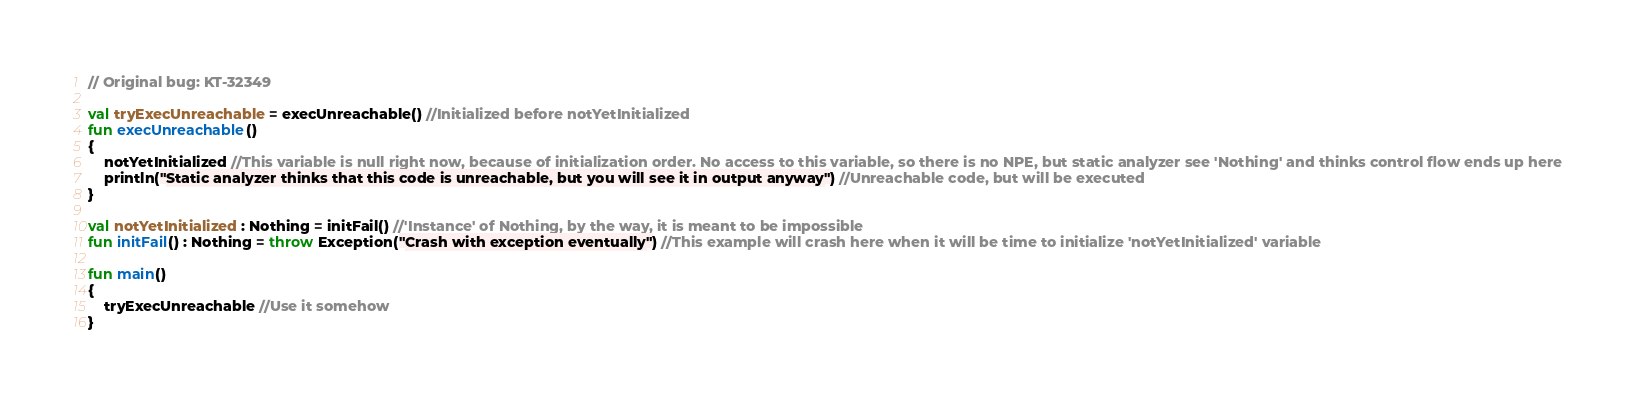<code> <loc_0><loc_0><loc_500><loc_500><_Kotlin_>// Original bug: KT-32349

val tryExecUnreachable = execUnreachable() //Initialized before notYetInitialized
fun execUnreachable()
{
	notYetInitialized //This variable is null right now, because of initialization order. No access to this variable, so there is no NPE, but static analyzer see 'Nothing' and thinks control flow ends up here
	println("Static analyzer thinks that this code is unreachable, but you will see it in output anyway") //Unreachable code, but will be executed
}

val notYetInitialized : Nothing = initFail() //'Instance' of Nothing, by the way, it is meant to be impossible
fun initFail() : Nothing = throw Exception("Crash with exception eventually") //This example will crash here when it will be time to initialize 'notYetInitialized' variable

fun main()
{
	tryExecUnreachable //Use it somehow
}
</code> 